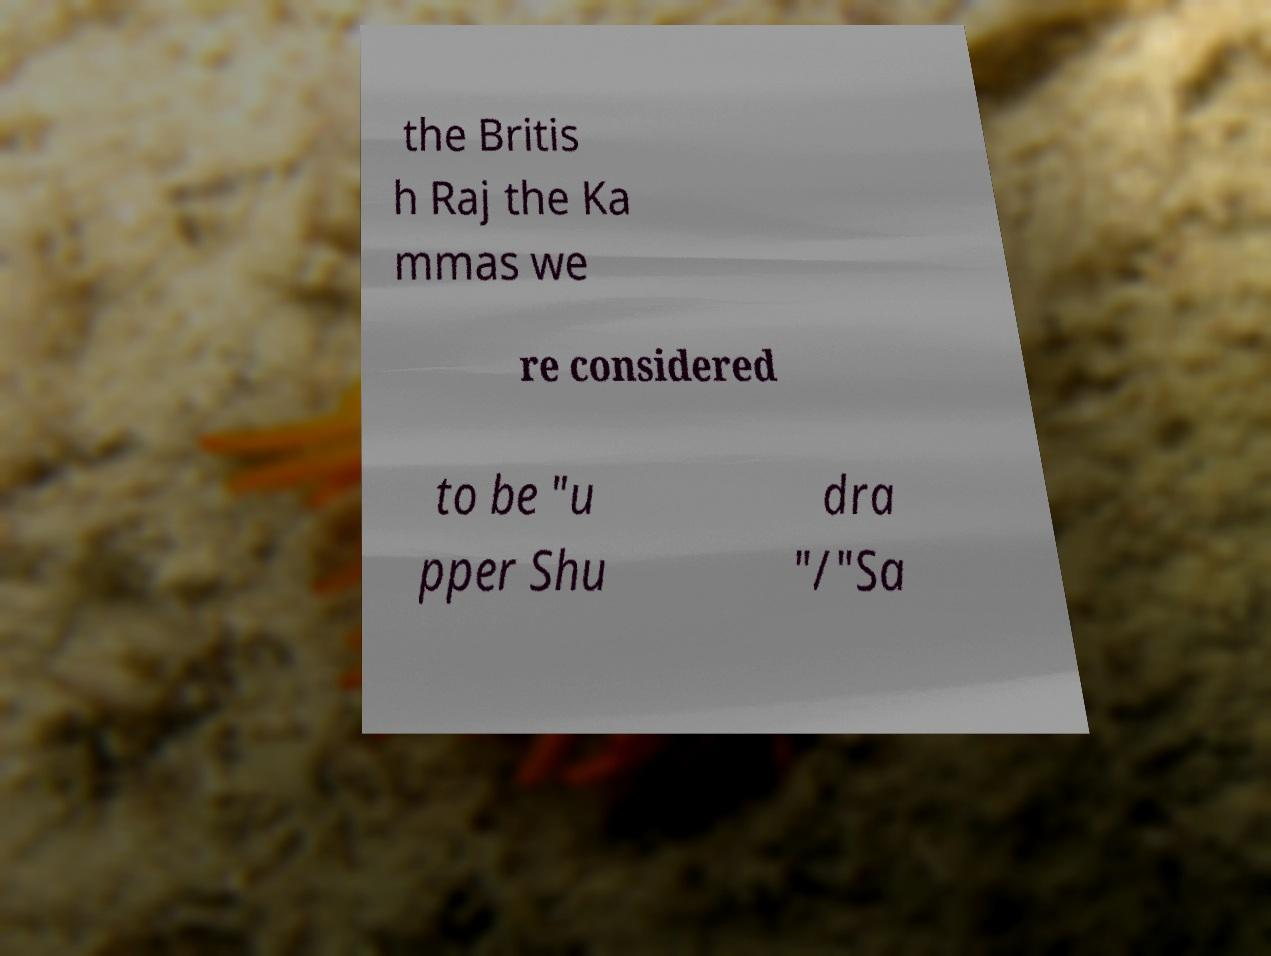Could you extract and type out the text from this image? the Britis h Raj the Ka mmas we re considered to be "u pper Shu dra "/"Sa 